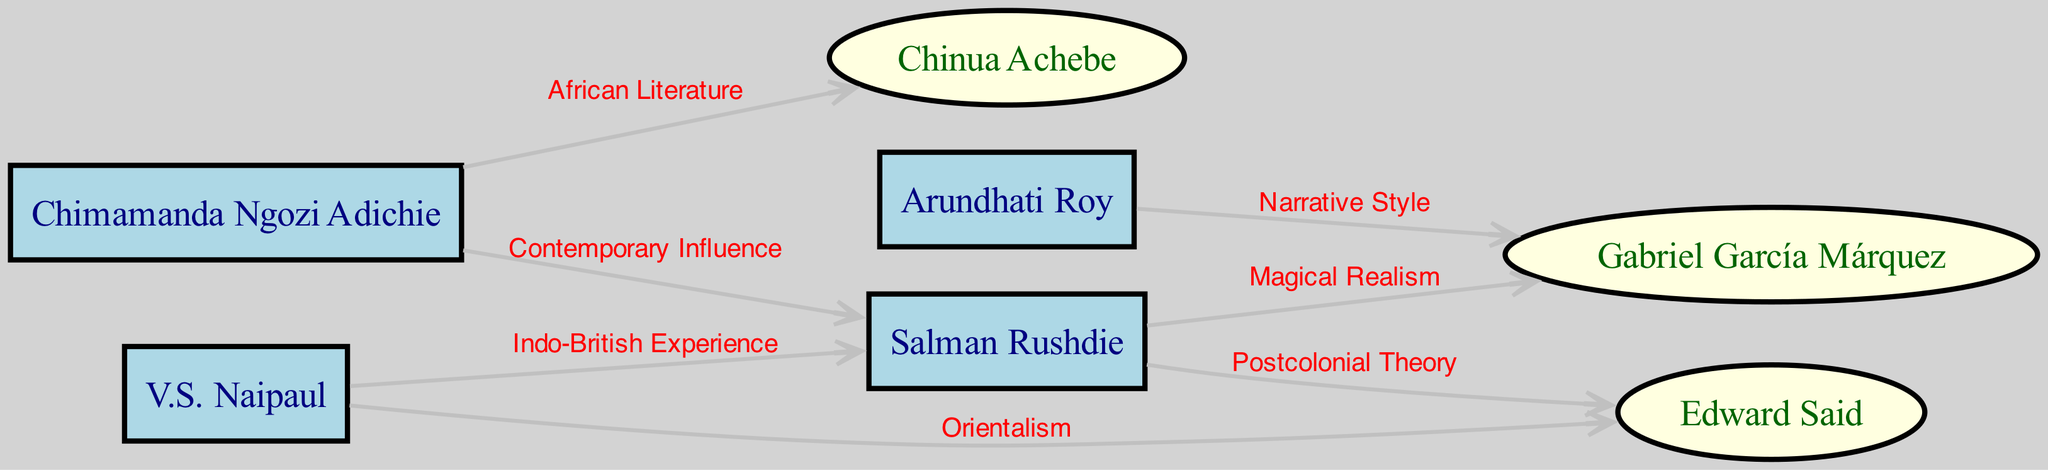What is the total number of authors in the diagram? The diagram includes nodes representing authors. By counting the entries under the "Author" type in the nodes section, we find that there are four distinct authors: Salman Rushdie, Chimamanda Ngozi Adichie, V.S. Naipaul, and Arundhati Roy.
Answer: 4 Which influence is connected to Salman Rushdie? Salman Rushdie has two edges leading to influences: one to Gabriel García Márquez, labeled "Magical Realism," and another to Edward Said, labeled "Postcolonial Theory." Therefore, the influences connected to Salman Rushdie are both of these, but "Magical Realism" is the first mention.
Answer: Gabriel García Márquez How many edges are there in total in the diagram? The diagram consists of a series of connections (edges) between the nodes (authors and influences). By counting the entries in the edges section, we find there are six distinct edges outlined.
Answer: 6 Which author is influenced by Chinua Achebe? The diagram indicates that Chimamanda Ngozi Adichie, has a direct connection to Chinua Achebe, labeled "African Literature." Thus, she is the author influenced by him.
Answer: Chimamanda Ngozi Adichie What is the relationship between V.S. Naipaul and Edward Said? There is an edge originating from V.S. Naipaul directed towards Edward Said, which explicitly states the label "Orientalism." This connection defines the influence of postcolonial theory concerning the themes explored by Naipaul.
Answer: Orientalism Who influences Chimamanda Ngozi Adichie? The only connection leading from Chimamanda Ngozi Adichie is towards Chinua Achebe, described with the label "African Literature." Thus, Achebe is the sole influence on Adichie.
Answer: Chinua Achebe Which author connects to the most influences? By reviewing the connections, Salman Rushdie connects to two influences (Gabriel García Márquez and Edward Said), while the others connect to either one or none. Therefore, he is the one who connects to the most influences.
Answer: Salman Rushdie What type of diagram is this? The diagram is a social network diagram illustrating author influences within postcolonial literature. It visually represents the relationships and connections between authors and their influences.
Answer: Social network diagram 